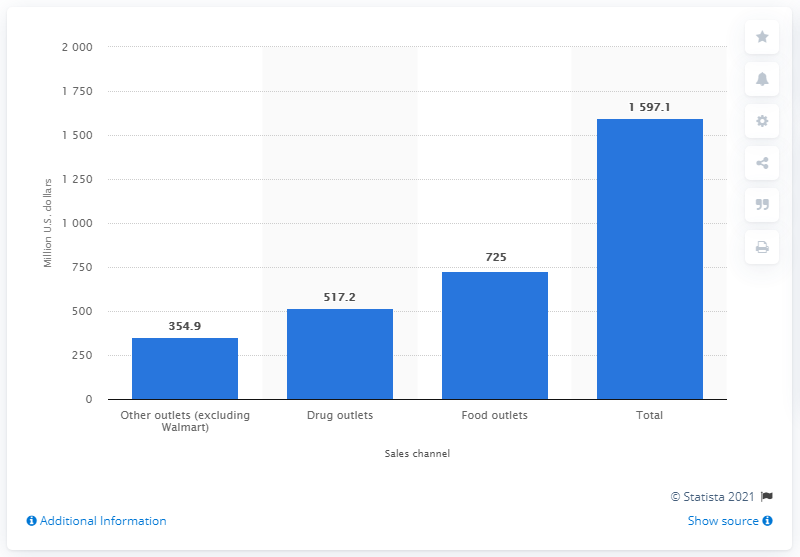List a handful of essential elements in this visual. The total amount of toothpaste sales in the United States in 2011/2012 was 1597.1 million units. In the United States, the sales of toothpaste through drug outlets in 2011/2012 were approximately $517.2 million. 